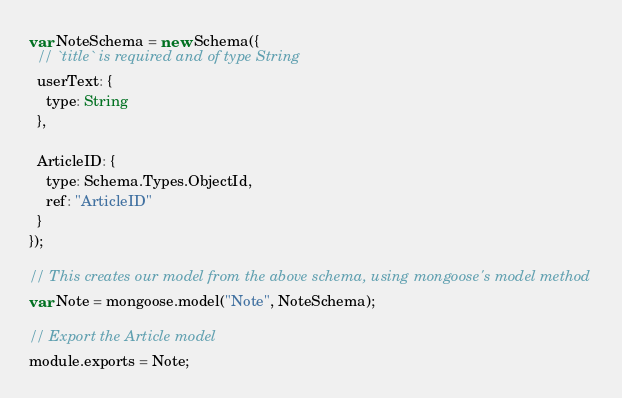Convert code to text. <code><loc_0><loc_0><loc_500><loc_500><_JavaScript_>var NoteSchema = new Schema({
  // `title` is required and of type String
  userText: {
    type: String
  },
 
  ArticleID: {
    type: Schema.Types.ObjectId,
    ref: "ArticleID"
  }
});

// This creates our model from the above schema, using mongoose's model method
var Note = mongoose.model("Note", NoteSchema);

// Export the Article model
module.exports = Note;</code> 